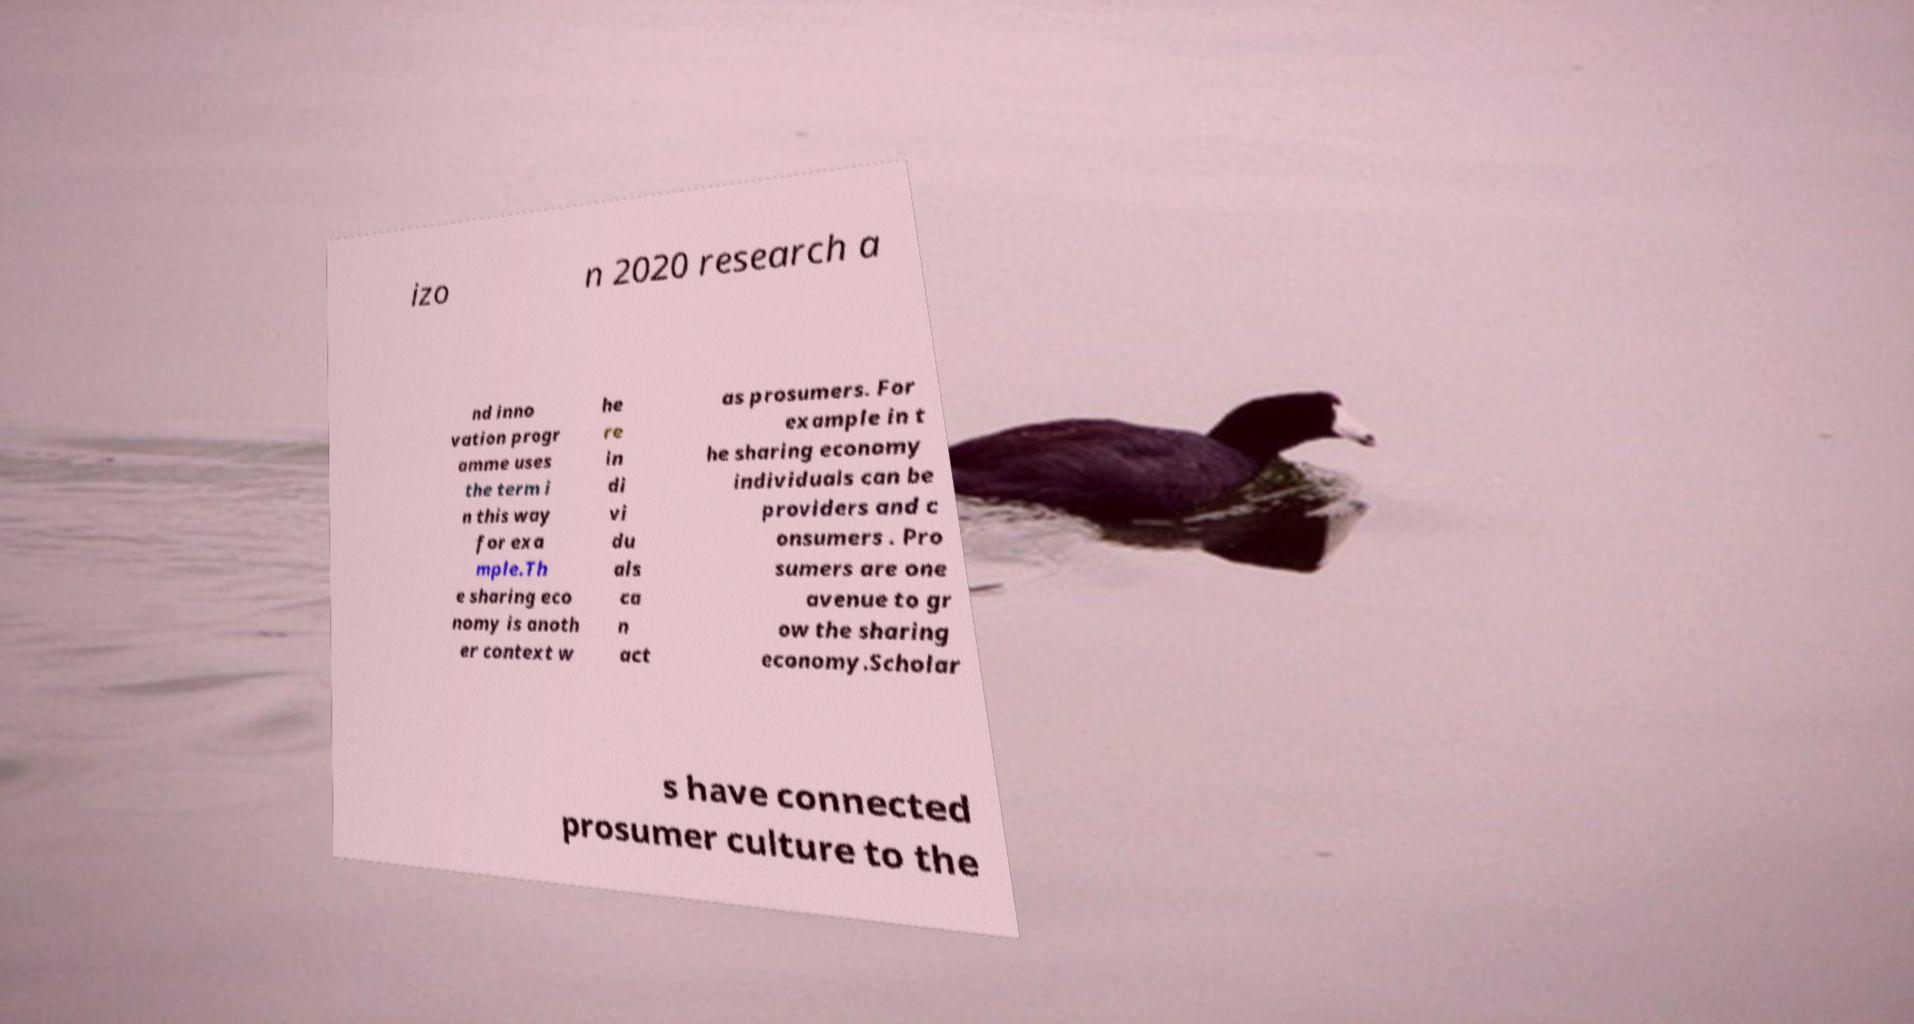Please read and relay the text visible in this image. What does it say? izo n 2020 research a nd inno vation progr amme uses the term i n this way for exa mple.Th e sharing eco nomy is anoth er context w he re in di vi du als ca n act as prosumers. For example in t he sharing economy individuals can be providers and c onsumers . Pro sumers are one avenue to gr ow the sharing economy.Scholar s have connected prosumer culture to the 